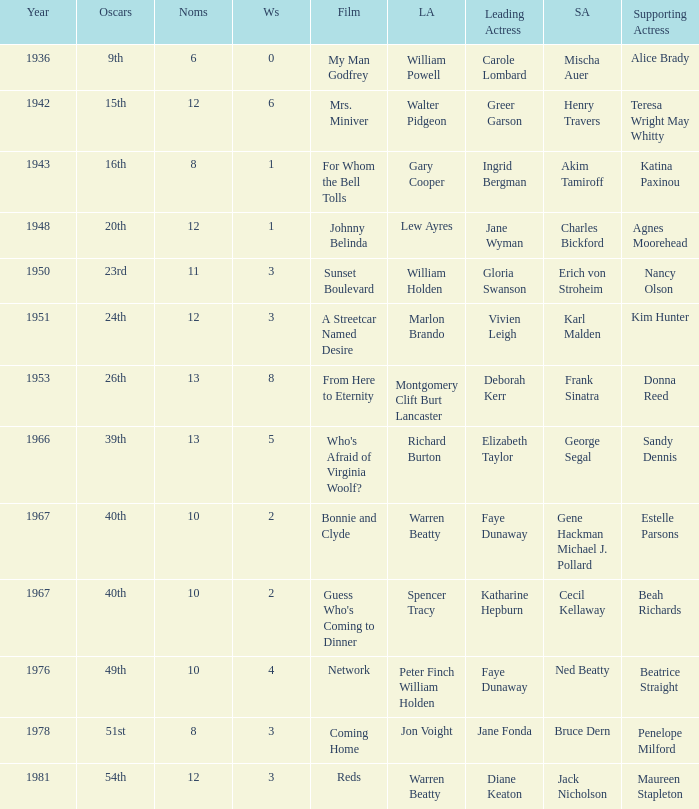Who was the leading actress in a film with Warren Beatty as the leading actor and also at the 40th Oscars? Faye Dunaway. 